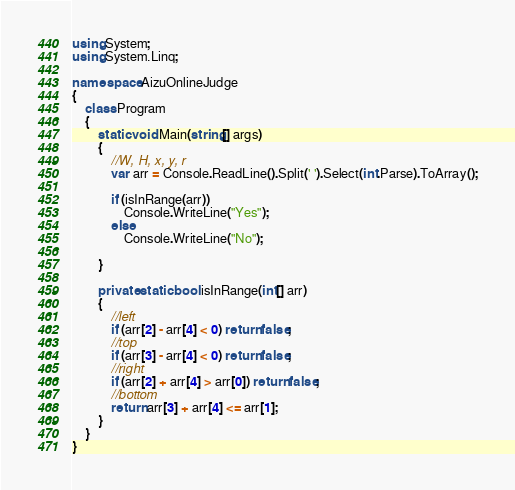<code> <loc_0><loc_0><loc_500><loc_500><_C#_>using System;
using System.Linq;

namespace AizuOnlineJudge
{
    class Program
    {
        static void Main(string[] args)
        {
            //W, H, x, y, r
            var arr = Console.ReadLine().Split(' ').Select(int.Parse).ToArray();

            if (isInRange(arr))
                Console.WriteLine("Yes");
            else
                Console.WriteLine("No");
            
        }

        private static bool isInRange(int[] arr)
        {
            //left
            if (arr[2] - arr[4] < 0) return false;
            //top
            if (arr[3] - arr[4] < 0) return false;
            //right
            if (arr[2] + arr[4] > arr[0]) return false;
            //bottom
            return arr[3] + arr[4] <= arr[1];
        }
    }
}

</code> 